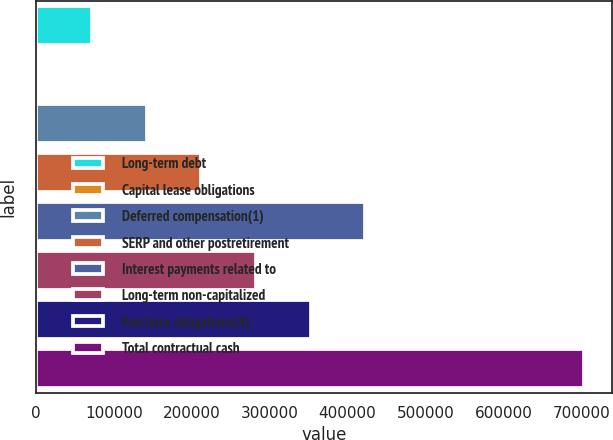Convert chart to OTSL. <chart><loc_0><loc_0><loc_500><loc_500><bar_chart><fcel>Long-term debt<fcel>Capital lease obligations<fcel>Deferred compensation(1)<fcel>SERP and other postretirement<fcel>Interest payments related to<fcel>Long-term non-capitalized<fcel>Purchase obligations(4)<fcel>Total contractual cash<nl><fcel>71636.3<fcel>1388<fcel>141885<fcel>212133<fcel>422878<fcel>282381<fcel>352630<fcel>703871<nl></chart> 